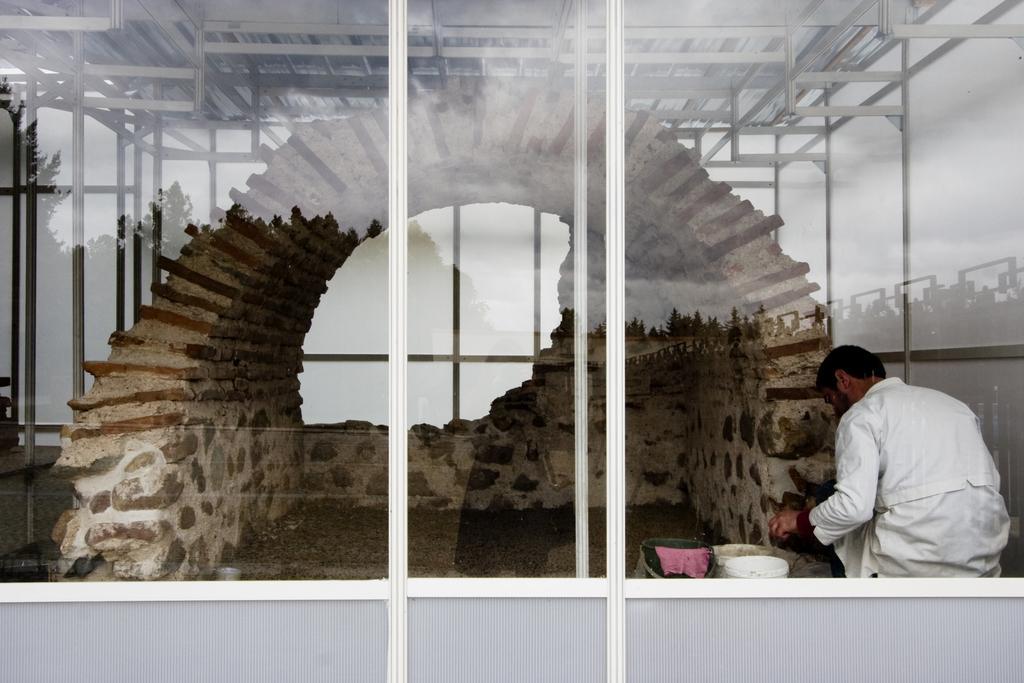Could you give a brief overview of what you see in this image? In this image there is a glass door in the middle. In side the glass door we can see that there is a man who is cementing the wall. At the top there are iron rods. 